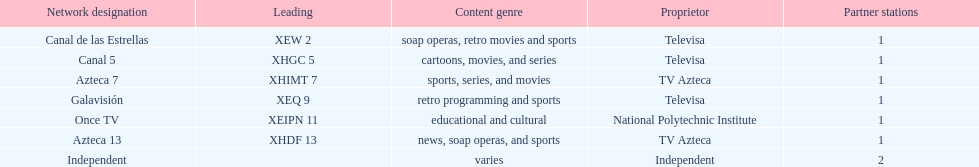How many affiliates does galavision have? 1. 